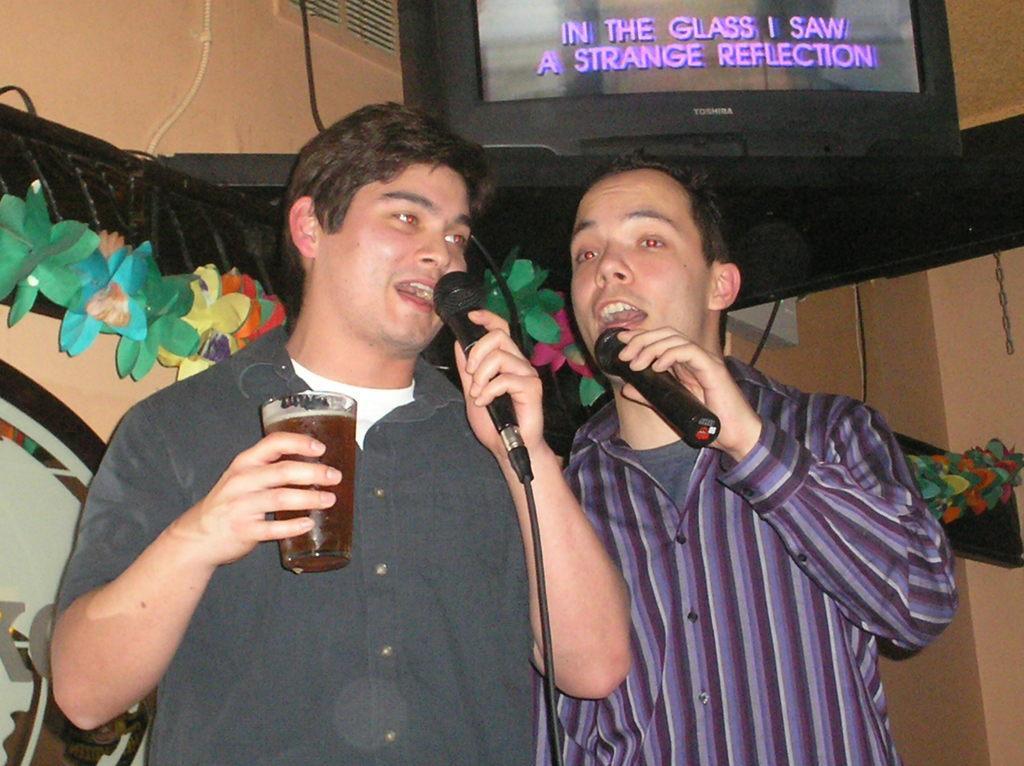Please provide a concise description of this image. In the image there are two men singing on mic holding a beer glass and above them there is a tv screen and back side of them there are flower ribbons. 